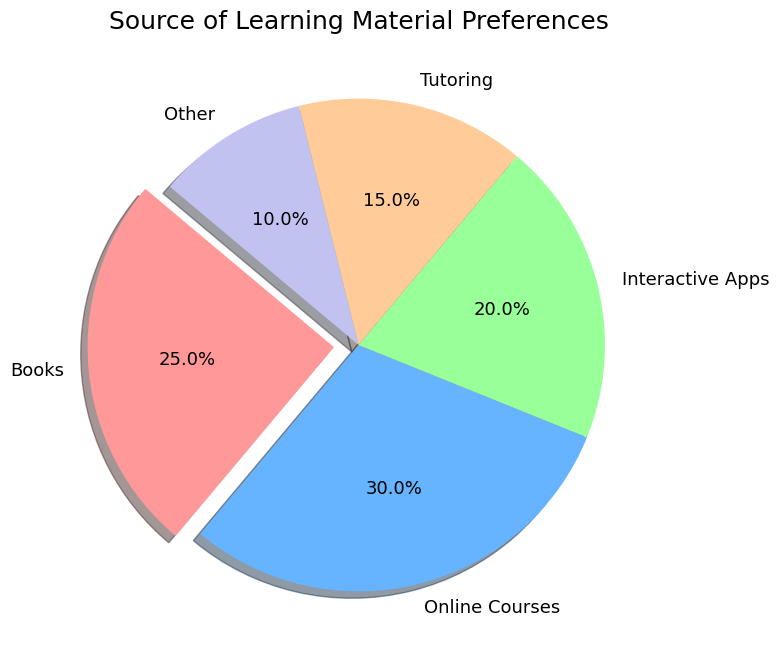What percentage of students prefer Books over Interactive Apps? To find the percentage of students preferring Books over Interactive Apps, compare their respective percentages. Books have 25%, and Interactive Apps have 20%.
Answer: 25% Which source of learning material has the smallest preference among students? To determine the source with the smallest preference, look at the percentages provided for each category. The 'Other' category has the lowest percentage at 10%.
Answer: Other What is the total percentage of students who prefer Online Courses and Tutoring combined? Add the percentages of students who prefer Online Courses (30%) and Tutoring (15%). The total is 30% + 15% = 45%.
Answer: 45% Which source of learning material has a preference percentage equal to the total percentage of Tutoring and Other combined? First, find the sum of the percentages for Tutoring (15%) and Other (10%), which is 15% + 10% = 25%. The source with a 25% preference is Books.
Answer: Books What are the visual attributes of the most preferred source of learning material? The most preferred source is Online Courses at 30%. It is represented with a label 'Online Courses' and occupies the largest segment of the pie chart without any explosion effect and is a distinct color (blue).
Answer: Label: Online Courses, Largest segment, Color: Blue How much more do students prefer Online Courses compared to Tutoring? Subtract the percentage of Tutoring (15%) from the percentage of Online Courses (30%). The difference is 30% - 15% = 15%.
Answer: 15% Is the combined preference for Books and Interactive Apps greater than the preference for Online Courses? Calculate the combined preference for Books (25%) and Interactive Apps (20%), which totals 25% + 20% = 45%. Since 45% is greater than the 30% preference for Online Courses, the combined preference is indeed greater.
Answer: Yes What fraction of students prefer sources other than Tutoring and Other? First, sum the percentages for Tutoring (15%) and Other (10%), which is 25%. The fraction of students preferring sources other than Tutoring and Other is 100% - 25% = 75%.
Answer: 75% Are Interactive Apps more preferred than Tutoring? Compare the percentages: Interactive Apps have 20% preference, while Tutoring has 15%. 20% is greater than 15%, thus, Interactive Apps are more preferred.
Answer: Yes 